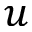<formula> <loc_0><loc_0><loc_500><loc_500>u</formula> 